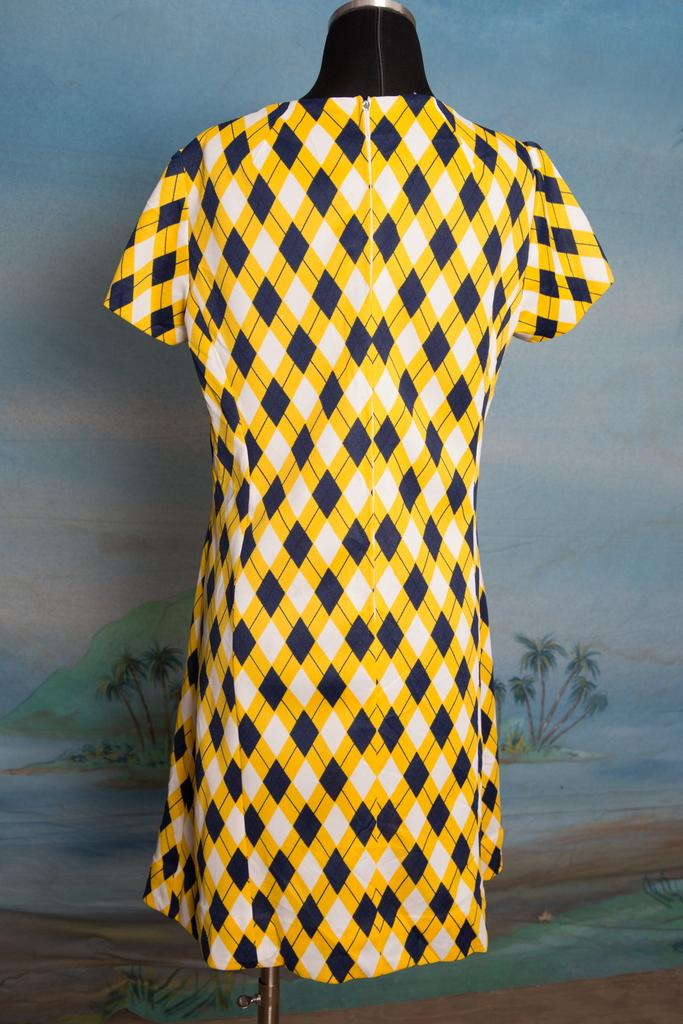What is the main subject in the center of the image? There is a dress on a mannequin in the center of the image. What can be seen in the background of the image? There is a board in the background of the image. What is depicted on the board? There is a scenery depicted on the board. What religion is being practiced in the image? There is no indication of any religious practice in the image; it features a dress on a mannequin and a board with a scenery. 